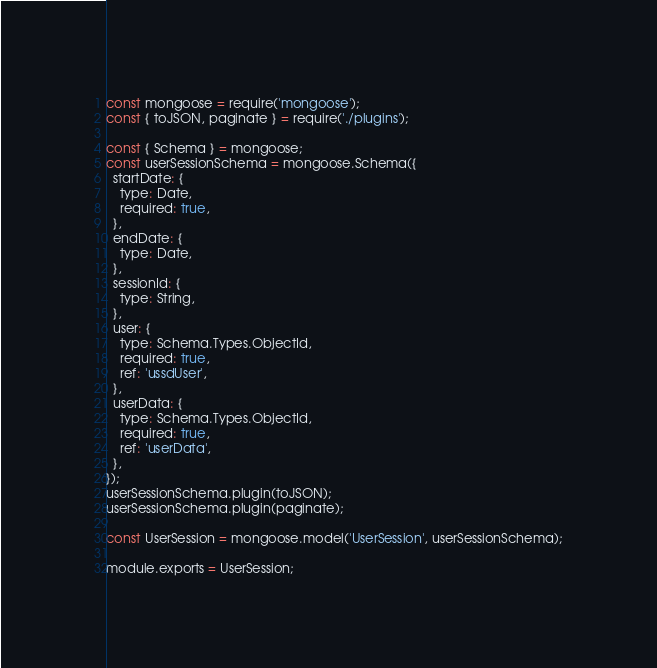Convert code to text. <code><loc_0><loc_0><loc_500><loc_500><_JavaScript_>const mongoose = require('mongoose');
const { toJSON, paginate } = require('./plugins');

const { Schema } = mongoose;
const userSessionSchema = mongoose.Schema({
  startDate: {
    type: Date,
    required: true,
  },
  endDate: {
    type: Date,
  },
  sessionId: {
    type: String,
  },
  user: {
    type: Schema.Types.ObjectId,
    required: true,
    ref: 'ussdUser',
  },
  userData: {
    type: Schema.Types.ObjectId,
    required: true,
    ref: 'userData',
  },
});
userSessionSchema.plugin(toJSON);
userSessionSchema.plugin(paginate);

const UserSession = mongoose.model('UserSession', userSessionSchema);

module.exports = UserSession;
</code> 